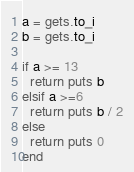<code> <loc_0><loc_0><loc_500><loc_500><_Ruby_>a = gets.to_i
b = gets.to_i
 
if a >= 13 
  return puts b
elsif a >=6 
  return puts b / 2
else
  return puts 0
end</code> 